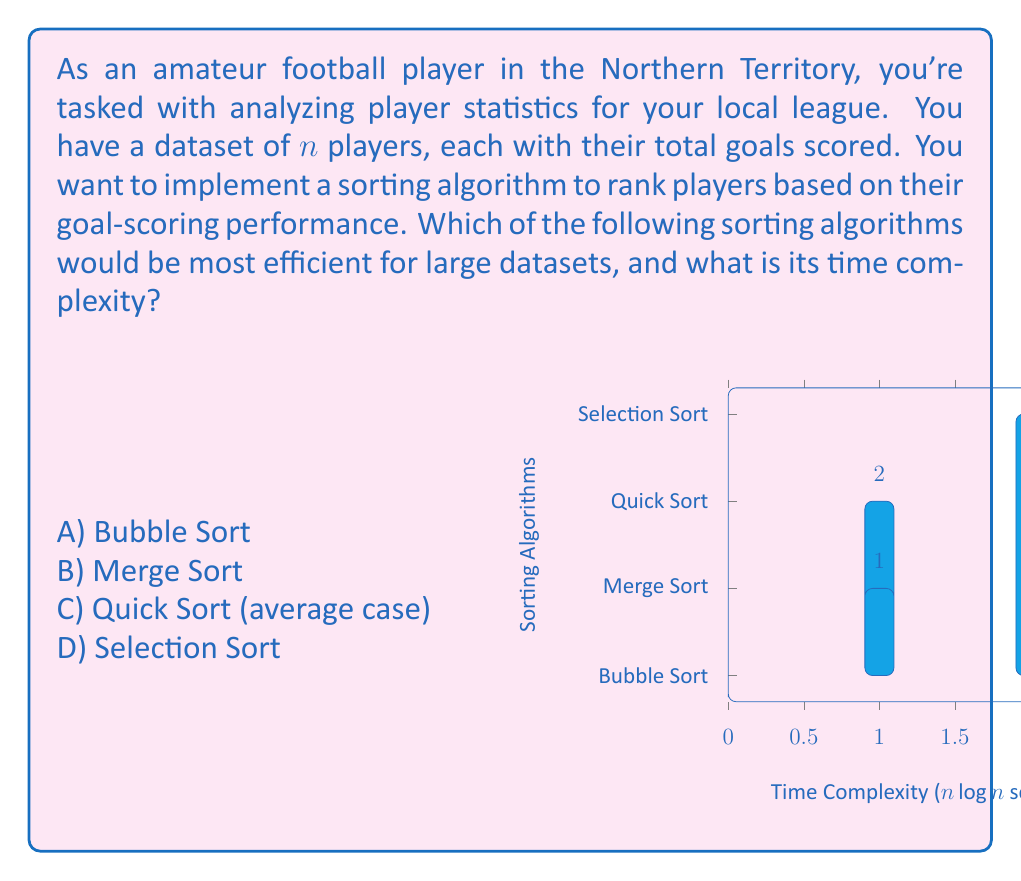Show me your answer to this math problem. Let's analyze the time complexity of each sorting algorithm:

1) Bubble Sort:
   - Time complexity: $O(n^2)$
   - For $n$ players, it compares adjacent elements $n-1$ times in the worst case.
   - Not efficient for large datasets.

2) Merge Sort:
   - Time complexity: $O(n \log n)$
   - Divides the list into halves recursively and merges them back.
   - Efficient for large datasets.

3) Quick Sort (average case):
   - Time complexity: $O(n \log n)$
   - Partitions the list around a pivot element recursively.
   - Efficient for large datasets, often faster than Merge Sort in practice.

4) Selection Sort:
   - Time complexity: $O(n^2)$
   - Finds the minimum element in each pass and places it at the beginning.
   - Not efficient for large datasets.

For large datasets of player statistics, we want an algorithm with $O(n \log n)$ complexity. Both Merge Sort and Quick Sort have this complexity, but Quick Sort is often faster in practice due to better cache performance and in-place sorting.

The graph in the question visually represents the time complexities, where Merge Sort and Quick Sort have lower (better) complexities compared to Bubble Sort and Selection Sort.

Therefore, Quick Sort (average case) would be the most efficient choice for sorting large datasets of player statistics.
Answer: C) Quick Sort (average case), $O(n \log n)$ 